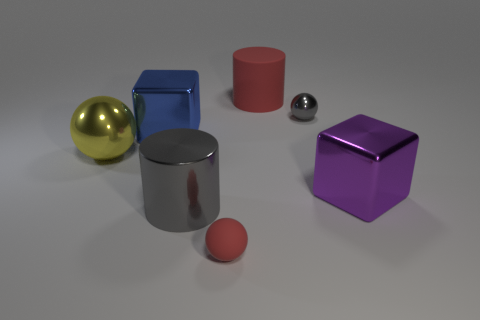Subtract all shiny spheres. How many spheres are left? 1 Add 2 large red matte objects. How many objects exist? 9 Subtract 1 cubes. How many cubes are left? 1 Subtract all red cylinders. How many cylinders are left? 1 Subtract all spheres. How many objects are left? 4 Add 7 small shiny things. How many small shiny things exist? 8 Subtract 1 red cylinders. How many objects are left? 6 Subtract all purple blocks. Subtract all brown balls. How many blocks are left? 1 Subtract all purple metal things. Subtract all rubber objects. How many objects are left? 4 Add 2 small red spheres. How many small red spheres are left? 3 